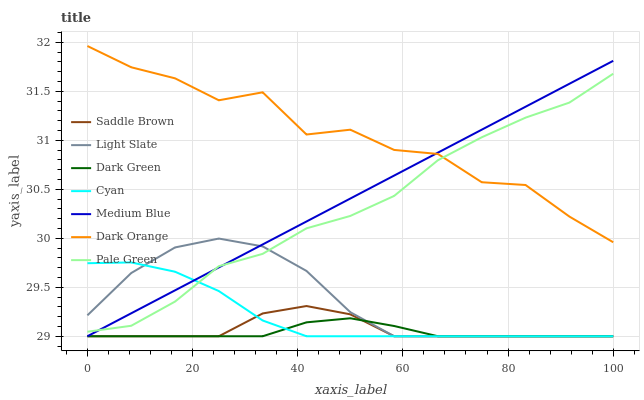Does Dark Green have the minimum area under the curve?
Answer yes or no. Yes. Does Dark Orange have the maximum area under the curve?
Answer yes or no. Yes. Does Light Slate have the minimum area under the curve?
Answer yes or no. No. Does Light Slate have the maximum area under the curve?
Answer yes or no. No. Is Medium Blue the smoothest?
Answer yes or no. Yes. Is Dark Orange the roughest?
Answer yes or no. Yes. Is Light Slate the smoothest?
Answer yes or no. No. Is Light Slate the roughest?
Answer yes or no. No. Does Light Slate have the lowest value?
Answer yes or no. Yes. Does Pale Green have the lowest value?
Answer yes or no. No. Does Dark Orange have the highest value?
Answer yes or no. Yes. Does Light Slate have the highest value?
Answer yes or no. No. Is Dark Green less than Pale Green?
Answer yes or no. Yes. Is Dark Orange greater than Light Slate?
Answer yes or no. Yes. Does Saddle Brown intersect Light Slate?
Answer yes or no. Yes. Is Saddle Brown less than Light Slate?
Answer yes or no. No. Is Saddle Brown greater than Light Slate?
Answer yes or no. No. Does Dark Green intersect Pale Green?
Answer yes or no. No. 